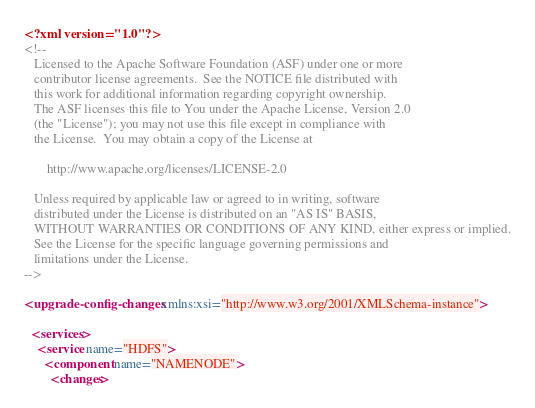<code> <loc_0><loc_0><loc_500><loc_500><_XML_><?xml version="1.0"?>
<!--
   Licensed to the Apache Software Foundation (ASF) under one or more
   contributor license agreements.  See the NOTICE file distributed with
   this work for additional information regarding copyright ownership.
   The ASF licenses this file to You under the Apache License, Version 2.0
   (the "License"); you may not use this file except in compliance with
   the License.  You may obtain a copy of the License at

       http://www.apache.org/licenses/LICENSE-2.0

   Unless required by applicable law or agreed to in writing, software
   distributed under the License is distributed on an "AS IS" BASIS,
   WITHOUT WARRANTIES OR CONDITIONS OF ANY KIND, either express or implied.
   See the License for the specific language governing permissions and
   limitations under the License.
-->

<upgrade-config-changes xmlns:xsi="http://www.w3.org/2001/XMLSchema-instance">

  <services>
    <service name="HDFS">
      <component name="NAMENODE">
        <changes></code> 